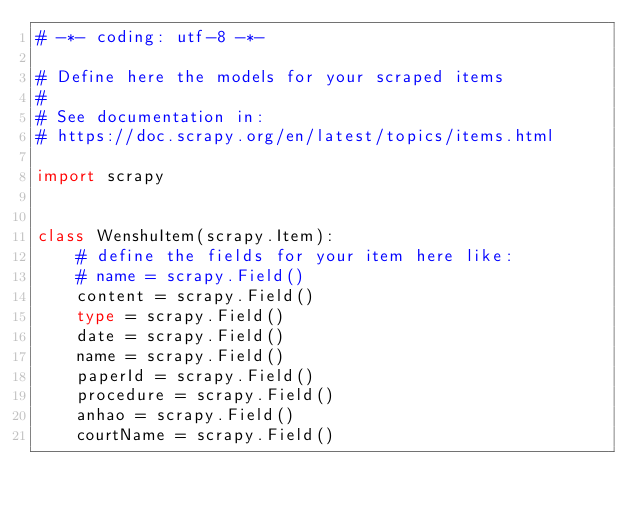<code> <loc_0><loc_0><loc_500><loc_500><_Python_># -*- coding: utf-8 -*-

# Define here the models for your scraped items
#
# See documentation in:
# https://doc.scrapy.org/en/latest/topics/items.html

import scrapy


class WenshuItem(scrapy.Item):
    # define the fields for your item here like:
    # name = scrapy.Field()
    content = scrapy.Field()
    type = scrapy.Field()
    date = scrapy.Field()
    name = scrapy.Field()
    paperId = scrapy.Field()
    procedure = scrapy.Field()
    anhao = scrapy.Field()
    courtName = scrapy.Field()

</code> 